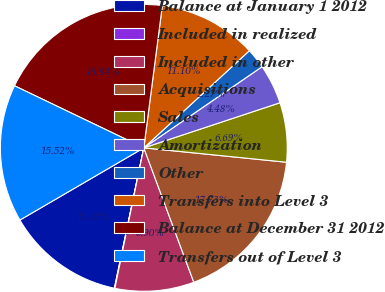<chart> <loc_0><loc_0><loc_500><loc_500><pie_chart><fcel>Balance at January 1 2012<fcel>Included in realized<fcel>Included in other<fcel>Acquisitions<fcel>Sales<fcel>Amortization<fcel>Other<fcel>Transfers into Level 3<fcel>Balance at December 31 2012<fcel>Transfers out of Level 3<nl><fcel>13.31%<fcel>0.06%<fcel>8.9%<fcel>17.73%<fcel>6.69%<fcel>4.48%<fcel>2.27%<fcel>11.1%<fcel>19.94%<fcel>15.52%<nl></chart> 